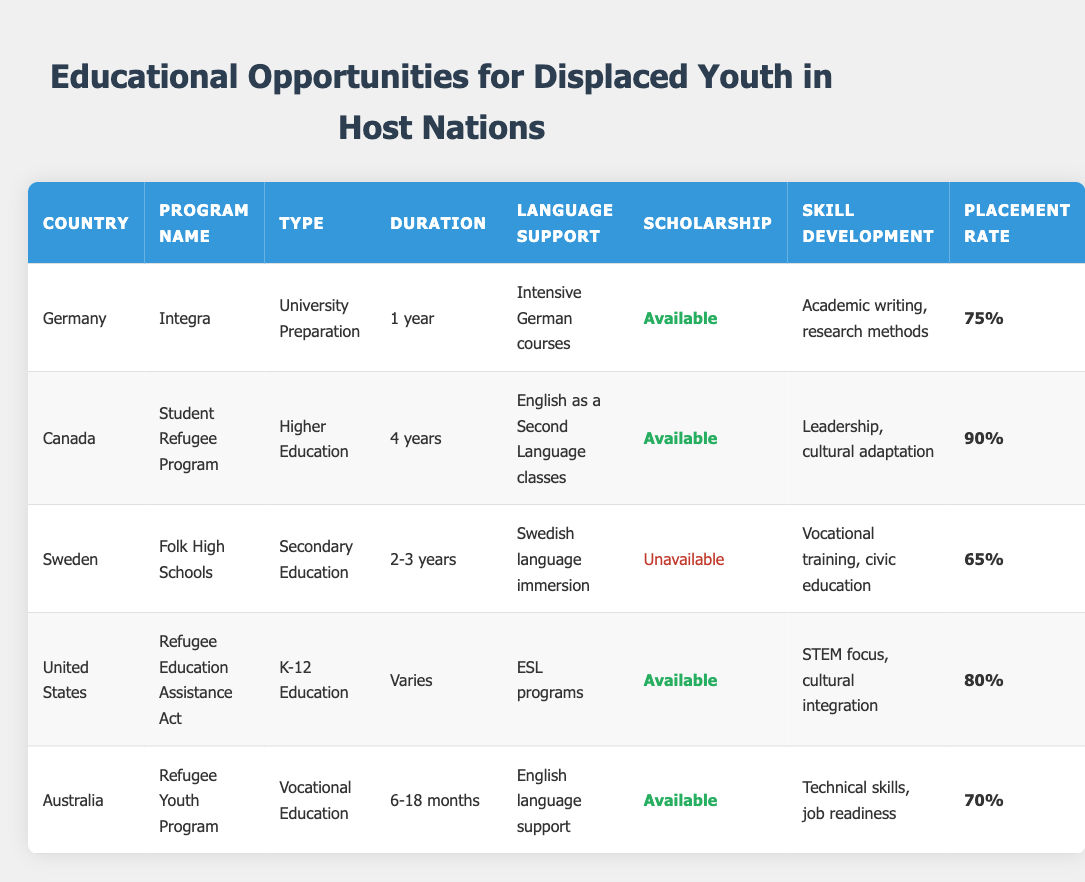What is the placement rate for the Canada program? The table shows that for Canada, the placement rate is listed as 90%.
Answer: 90% Is there a scholarship available for the Sweden program? Referring to the table, the Sweden program states that the scholarship is marked as unavailable.
Answer: No How many years does the Germany program last? The duration for the Germany program is provided in the table as 1 year.
Answer: 1 year Which program has the lowest placement rate? By reviewing the placement rates in the table, Sweden has the lowest rate at 65%, while the other programs are higher.
Answer: 65% What types of educational opportunities are offered in the United States? According to the table, the United States offers K-12 Education through the Refugee Education Assistance Act program.
Answer: K-12 Education Which country offers a program with the longest duration? The table indicates that Canada offers a higher education program with a duration of 4 years, which is longer than any other listed program.
Answer: Canada (4 years) What is the average duration of the programs listed in the table? The durations are 1 year (Germany), 4 years (Canada), 2.5 years (average of 2-3 years, Sweden), varies (US), and 12 months (average of 6-18 months, Australia). The total duration is 1 + 4 + 2.5 + 0 + 1 (assuming 1 year for Varies) = 9.5. There are 5 programs, so average = 9.5/5 = 1.9 years.
Answer: 1.9 years Which program offers intensive language support? The Germany program specifically mentions "Intensive German courses" for language support, making it stand out in that category.
Answer: Germany Is the skill development focus the same for the Germany and Australia programs? The table shows that Germany focuses on academic writing and research methods, while Australia emphasizes technical skills and job readiness, indicating different skill focuses.
Answer: No 